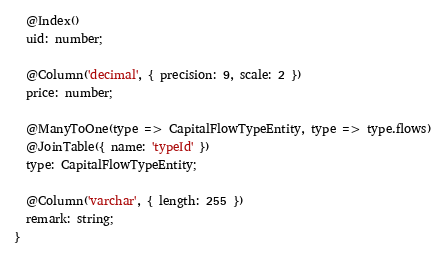Convert code to text. <code><loc_0><loc_0><loc_500><loc_500><_TypeScript_>  @Index()
  uid: number;

  @Column('decimal', { precision: 9, scale: 2 })
  price: number;

  @ManyToOne(type => CapitalFlowTypeEntity, type => type.flows)
  @JoinTable({ name: 'typeId' })
  type: CapitalFlowTypeEntity;

  @Column('varchar', { length: 255 })
  remark: string;
}
</code> 